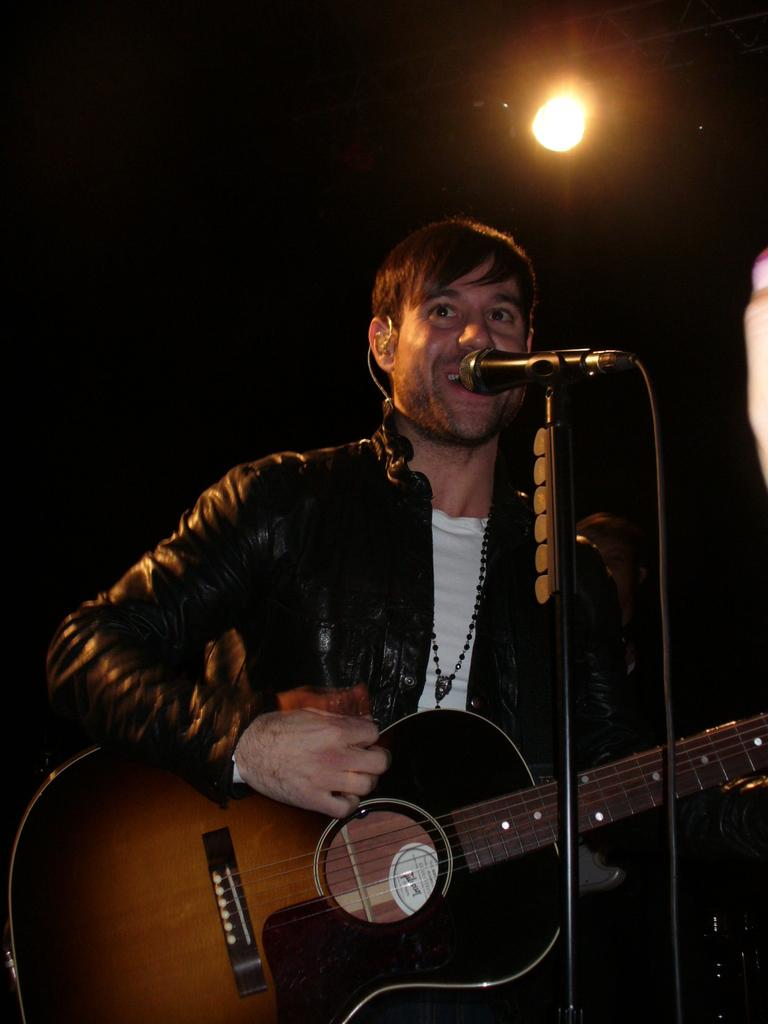What is the person in the image doing? The person is playing a guitar. What object is the person using to amplify their voice? The person is in front of a microphone. Can you describe the lighting in the image? There is a light in the background of the image. What type of machine is being used to promote peace in the image? There is no machine or reference to promoting peace in the image; it features a person playing a guitar in front of a microphone with a light in the background. 